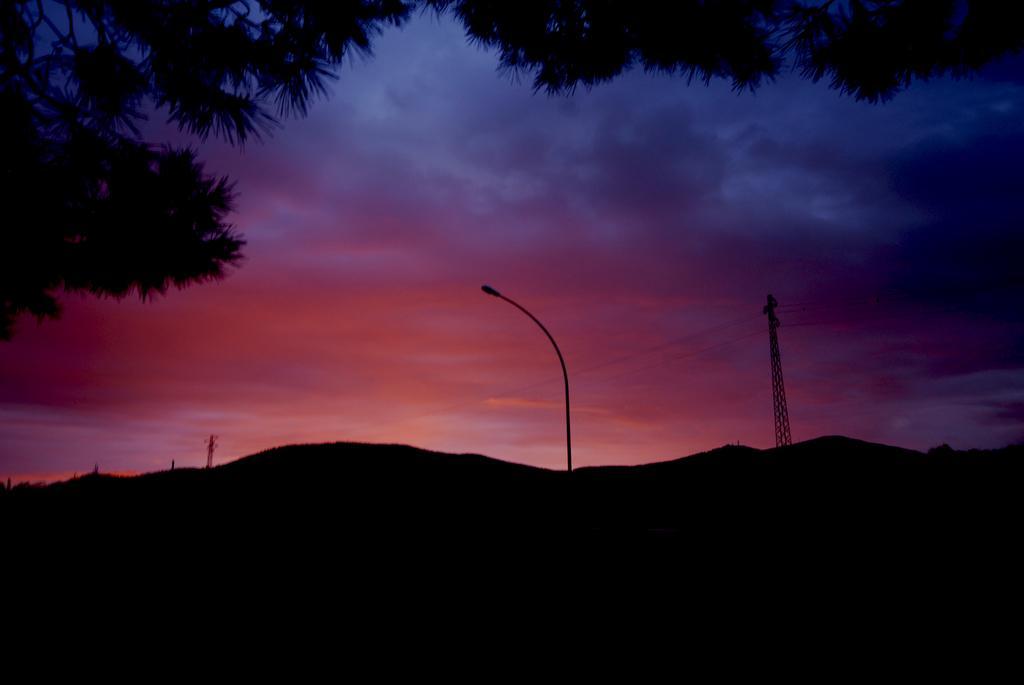Please provide a concise description of this image. In the center of the image we can see light pole, metal frames with cables. In the background, we can see mountains, trees and the cloudy sky. 